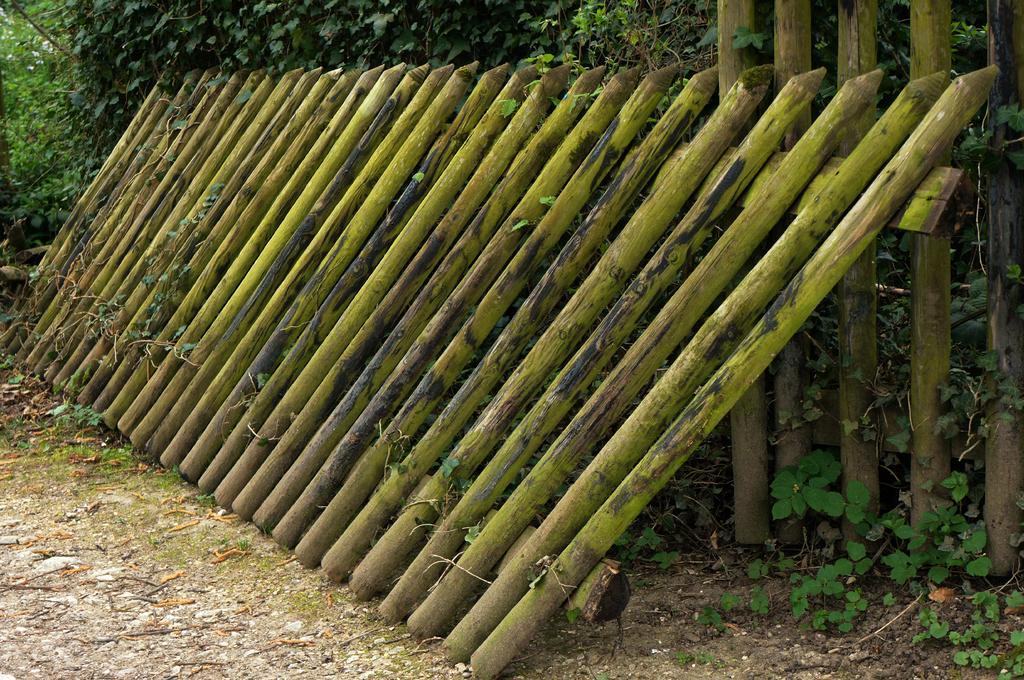How would you summarize this image in a sentence or two? This image consists of some sticks in the middle. There are trees at the top. 